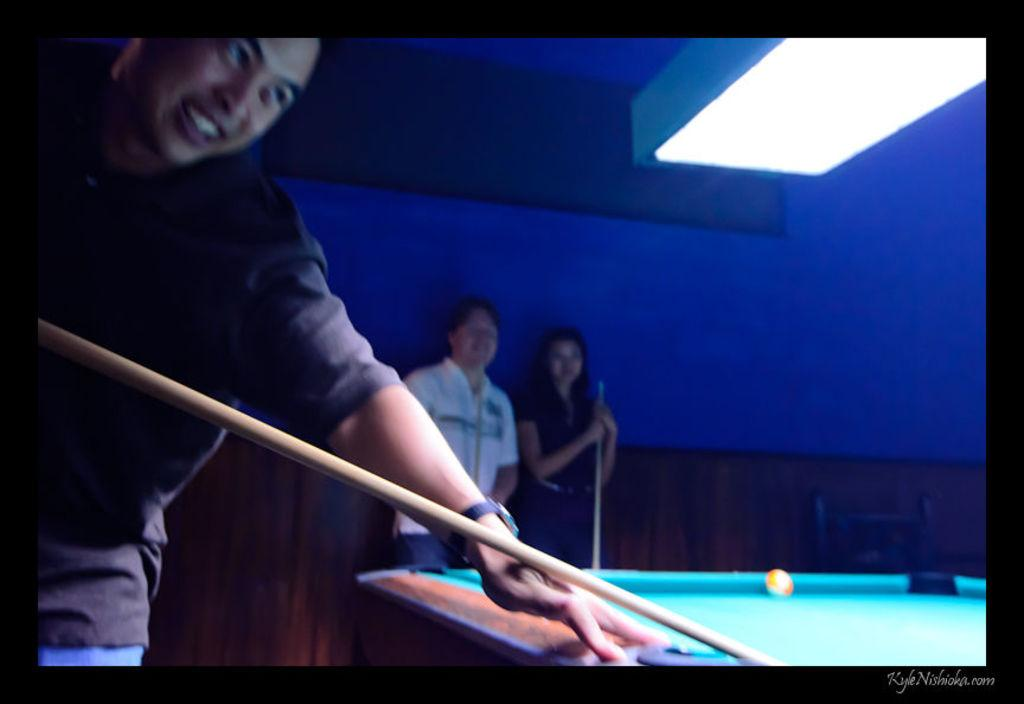How many people are in the image? There are persons in the image, but the exact number is not specified. What is one person holding in the image? One person is holding a stick in the image. What piece of furniture is present in the image? There is a table in the image. What object is round and can be used for playing in the image? There is a ball in the image. What type of cord is being used to tie the ball in the image? There is no cord present in the image, and the ball is not tied. 